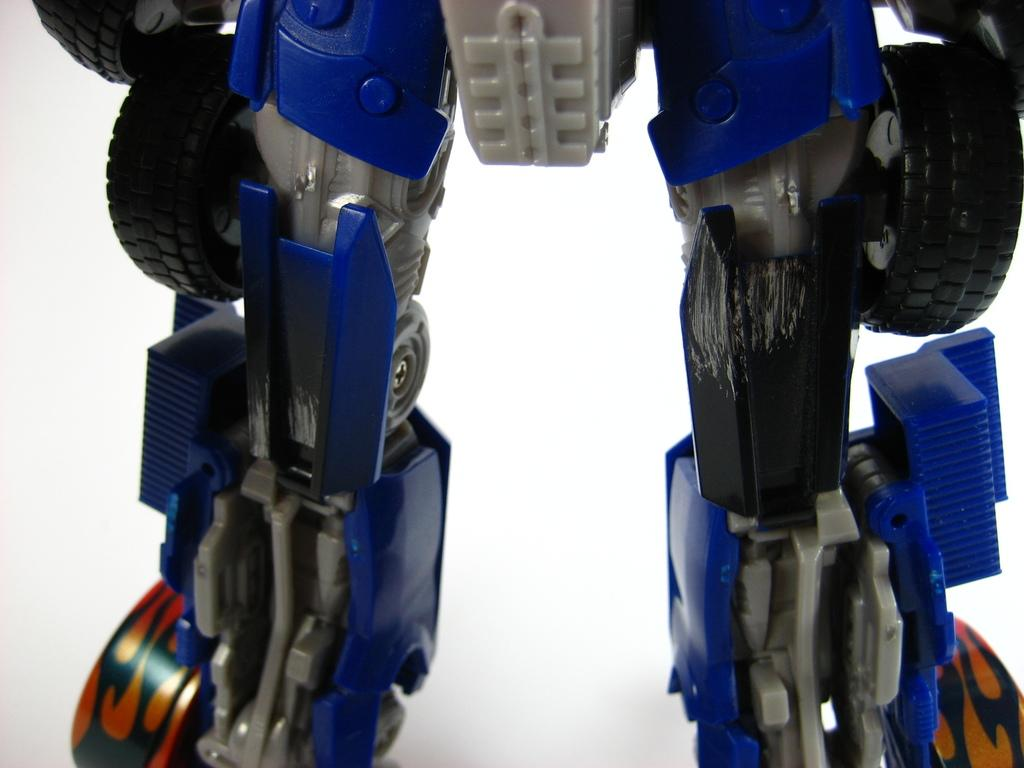What object is present in the image? There is a toy in the image. What colors can be seen on the toy? The toy has blue and black colors. What color is the background of the image? The background of the image is white. Can you see a crow interacting with the toy in the image? There is no crow present in the image, and therefore no interaction with the toy can be observed. 